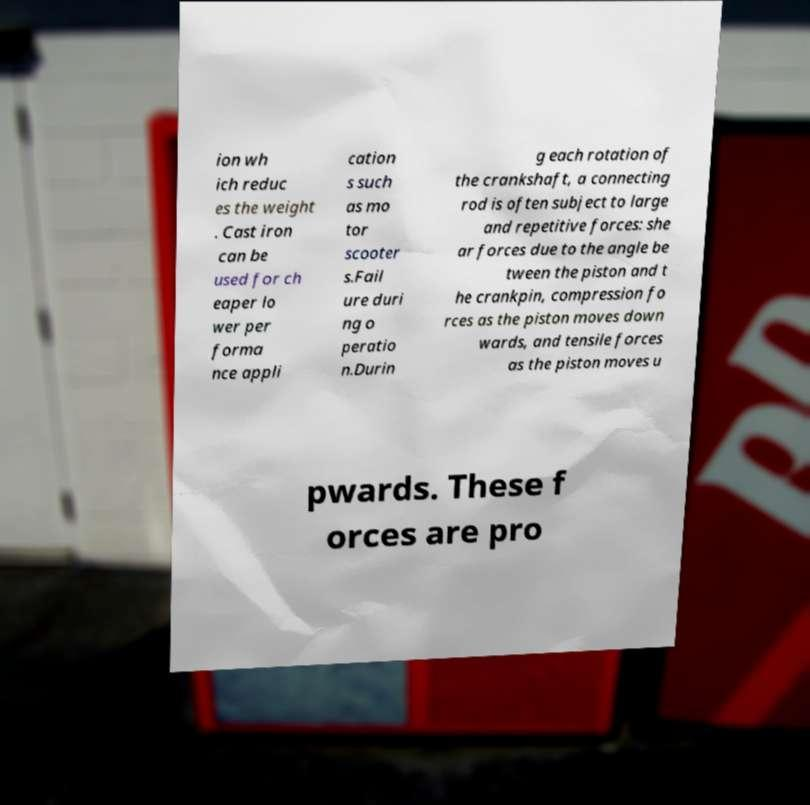Please identify and transcribe the text found in this image. ion wh ich reduc es the weight . Cast iron can be used for ch eaper lo wer per forma nce appli cation s such as mo tor scooter s.Fail ure duri ng o peratio n.Durin g each rotation of the crankshaft, a connecting rod is often subject to large and repetitive forces: she ar forces due to the angle be tween the piston and t he crankpin, compression fo rces as the piston moves down wards, and tensile forces as the piston moves u pwards. These f orces are pro 